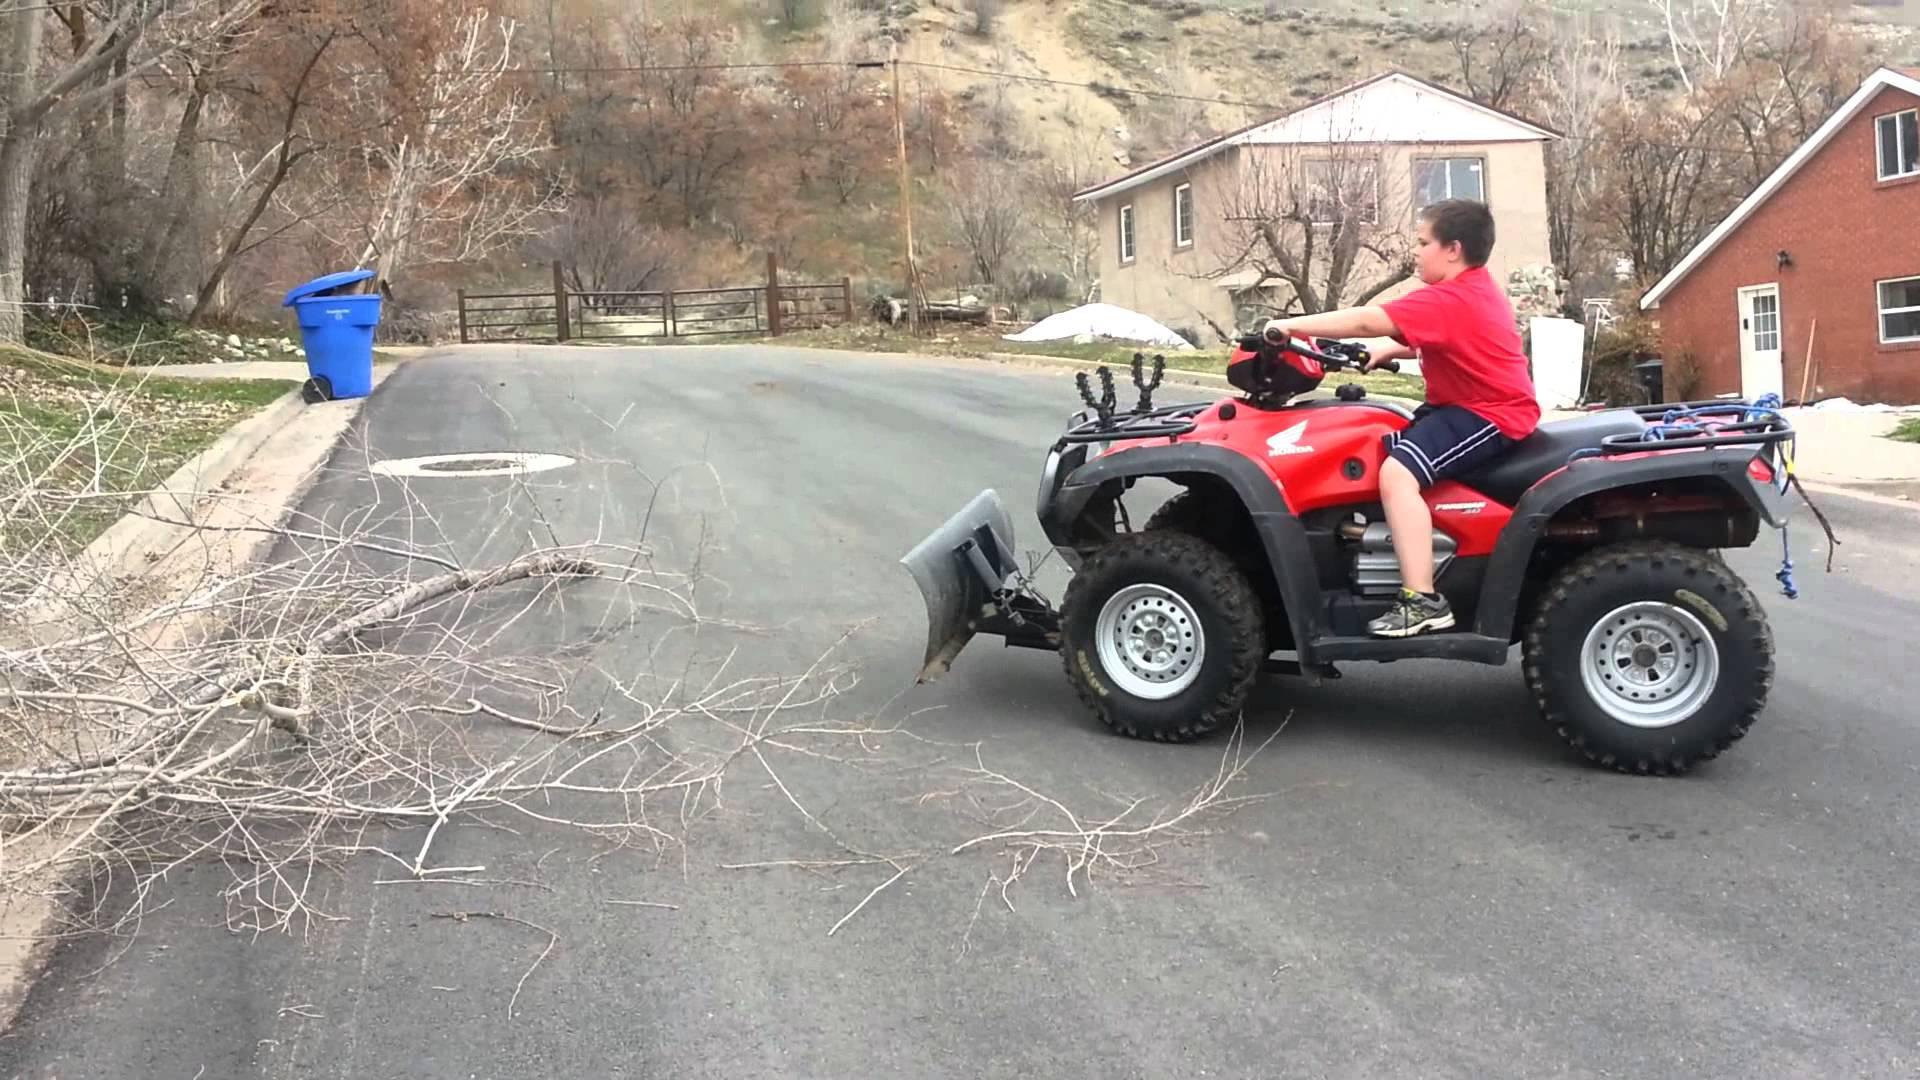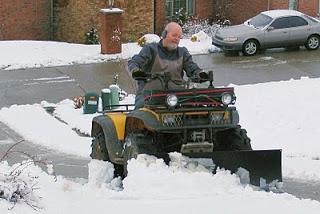The first image is the image on the left, the second image is the image on the right. Analyze the images presented: Is the assertion "All four wheelers are in snowy areas and have drivers." valid? Answer yes or no. No. The first image is the image on the left, the second image is the image on the right. Assess this claim about the two images: "There are two 4 wheelers near houses.". Correct or not? Answer yes or no. Yes. 